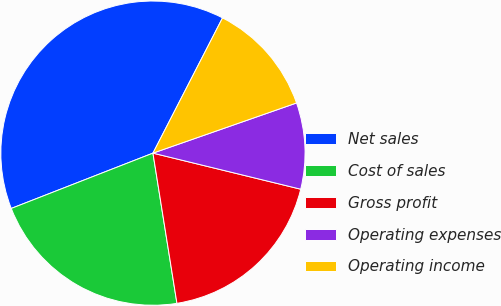<chart> <loc_0><loc_0><loc_500><loc_500><pie_chart><fcel>Net sales<fcel>Cost of sales<fcel>Gross profit<fcel>Operating expenses<fcel>Operating income<nl><fcel>38.49%<fcel>21.6%<fcel>18.67%<fcel>9.16%<fcel>12.09%<nl></chart> 